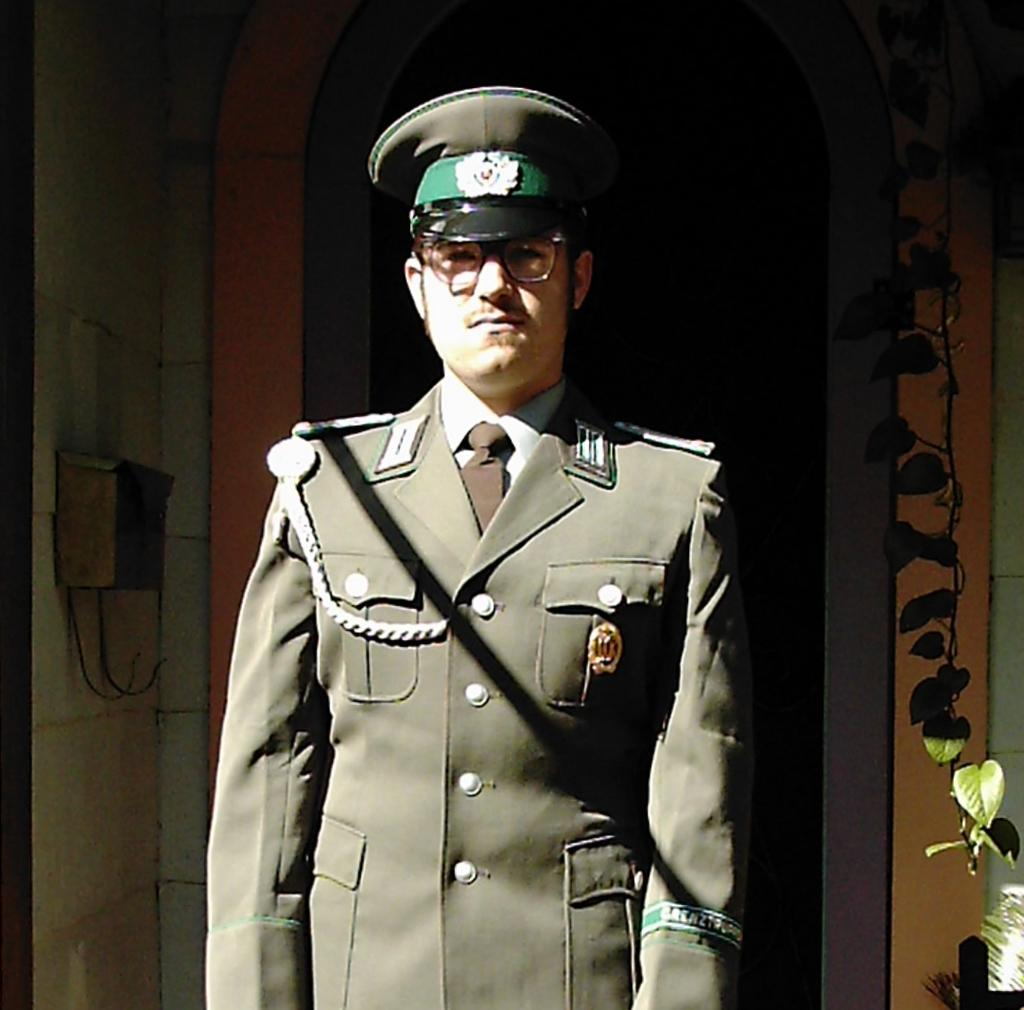Who is present in the image? There is a man in the image. What is the man's position in the image? The man is standing in front. What is the man wearing in the image? The man is wearing a uniform, a cap, and spectacles. What other object can be seen in the image? There is a letter box in the image. Where is the letter box located in the image? The letter box is kept on a wall. How many girls are waving good-bye to the man in the image? There are no girls present in the image, nor is anyone waving good-bye. What is the man's reaction to the surprise in the image? There is no surprise present in the image, so the man's reaction cannot be determined. 